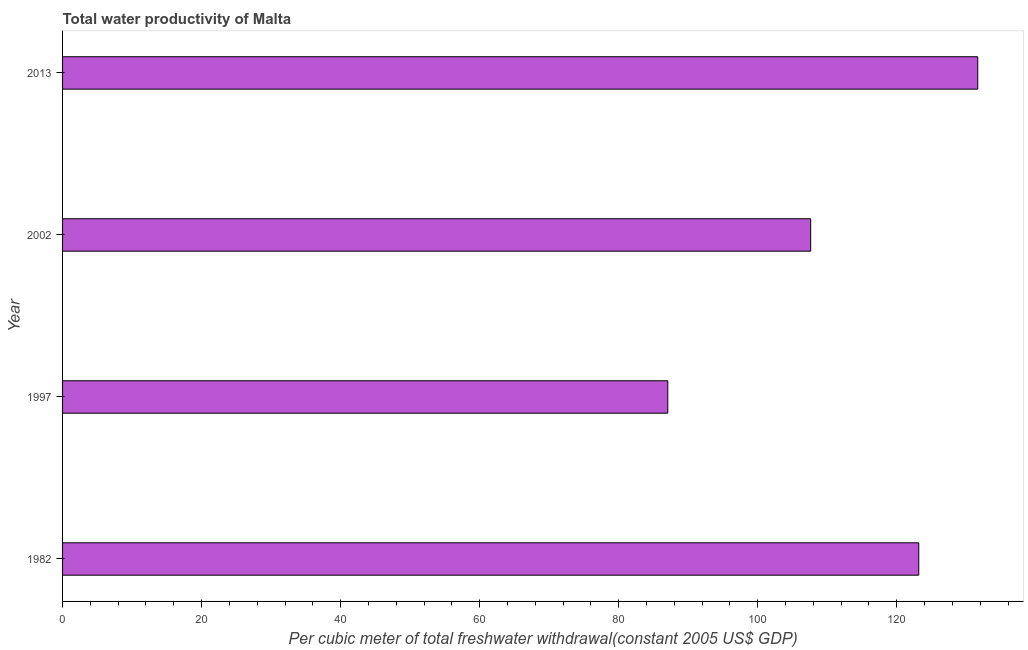What is the title of the graph?
Provide a short and direct response. Total water productivity of Malta. What is the label or title of the X-axis?
Offer a very short reply. Per cubic meter of total freshwater withdrawal(constant 2005 US$ GDP). What is the label or title of the Y-axis?
Your answer should be very brief. Year. What is the total water productivity in 1997?
Offer a terse response. 87.06. Across all years, what is the maximum total water productivity?
Provide a succinct answer. 131.65. Across all years, what is the minimum total water productivity?
Your response must be concise. 87.06. What is the sum of the total water productivity?
Make the answer very short. 449.48. What is the difference between the total water productivity in 1997 and 2002?
Keep it short and to the point. -20.55. What is the average total water productivity per year?
Ensure brevity in your answer.  112.37. What is the median total water productivity?
Make the answer very short. 115.39. In how many years, is the total water productivity greater than 72 US$?
Your answer should be compact. 4. What is the ratio of the total water productivity in 1982 to that in 2013?
Give a very brief answer. 0.94. What is the difference between the highest and the second highest total water productivity?
Make the answer very short. 8.48. What is the difference between the highest and the lowest total water productivity?
Your response must be concise. 44.58. In how many years, is the total water productivity greater than the average total water productivity taken over all years?
Your response must be concise. 2. How many years are there in the graph?
Offer a very short reply. 4. What is the difference between two consecutive major ticks on the X-axis?
Ensure brevity in your answer.  20. What is the Per cubic meter of total freshwater withdrawal(constant 2005 US$ GDP) of 1982?
Make the answer very short. 123.16. What is the Per cubic meter of total freshwater withdrawal(constant 2005 US$ GDP) in 1997?
Keep it short and to the point. 87.06. What is the Per cubic meter of total freshwater withdrawal(constant 2005 US$ GDP) of 2002?
Your answer should be compact. 107.61. What is the Per cubic meter of total freshwater withdrawal(constant 2005 US$ GDP) of 2013?
Provide a succinct answer. 131.65. What is the difference between the Per cubic meter of total freshwater withdrawal(constant 2005 US$ GDP) in 1982 and 1997?
Offer a terse response. 36.1. What is the difference between the Per cubic meter of total freshwater withdrawal(constant 2005 US$ GDP) in 1982 and 2002?
Offer a terse response. 15.55. What is the difference between the Per cubic meter of total freshwater withdrawal(constant 2005 US$ GDP) in 1982 and 2013?
Ensure brevity in your answer.  -8.48. What is the difference between the Per cubic meter of total freshwater withdrawal(constant 2005 US$ GDP) in 1997 and 2002?
Provide a short and direct response. -20.55. What is the difference between the Per cubic meter of total freshwater withdrawal(constant 2005 US$ GDP) in 1997 and 2013?
Your answer should be compact. -44.58. What is the difference between the Per cubic meter of total freshwater withdrawal(constant 2005 US$ GDP) in 2002 and 2013?
Offer a terse response. -24.03. What is the ratio of the Per cubic meter of total freshwater withdrawal(constant 2005 US$ GDP) in 1982 to that in 1997?
Ensure brevity in your answer.  1.42. What is the ratio of the Per cubic meter of total freshwater withdrawal(constant 2005 US$ GDP) in 1982 to that in 2002?
Provide a short and direct response. 1.14. What is the ratio of the Per cubic meter of total freshwater withdrawal(constant 2005 US$ GDP) in 1982 to that in 2013?
Make the answer very short. 0.94. What is the ratio of the Per cubic meter of total freshwater withdrawal(constant 2005 US$ GDP) in 1997 to that in 2002?
Offer a very short reply. 0.81. What is the ratio of the Per cubic meter of total freshwater withdrawal(constant 2005 US$ GDP) in 1997 to that in 2013?
Offer a terse response. 0.66. What is the ratio of the Per cubic meter of total freshwater withdrawal(constant 2005 US$ GDP) in 2002 to that in 2013?
Your answer should be very brief. 0.82. 